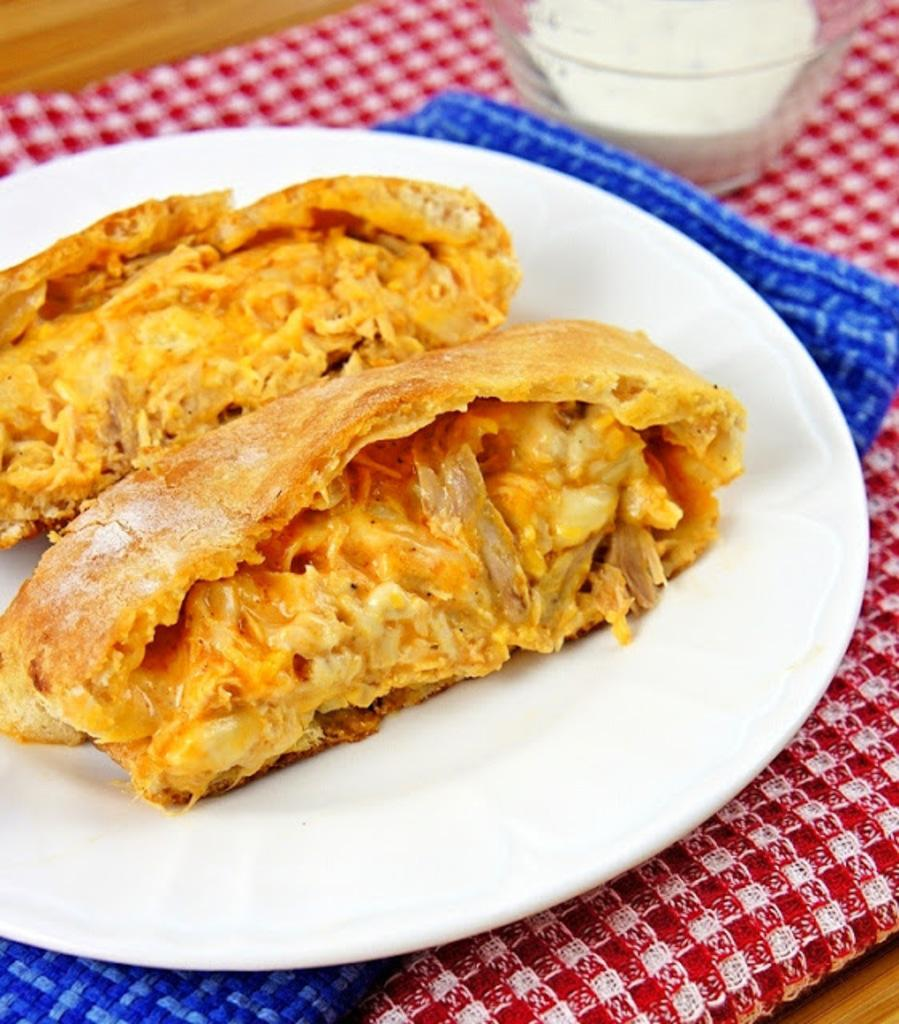What is on the plate that is visible in the image? There is food on a plate in the image. Where is the plate located in the image? The plate is placed on a table in the image. What else can be seen in the top right corner of the image? There is a bowl in the top right corner of the image. What type of event is taking place in the image? There is no indication of an event taking place in the image; it simply shows food on a plate and a bowl. Can you see a fly buzzing around the food in the image? There is no fly visible in the image. 